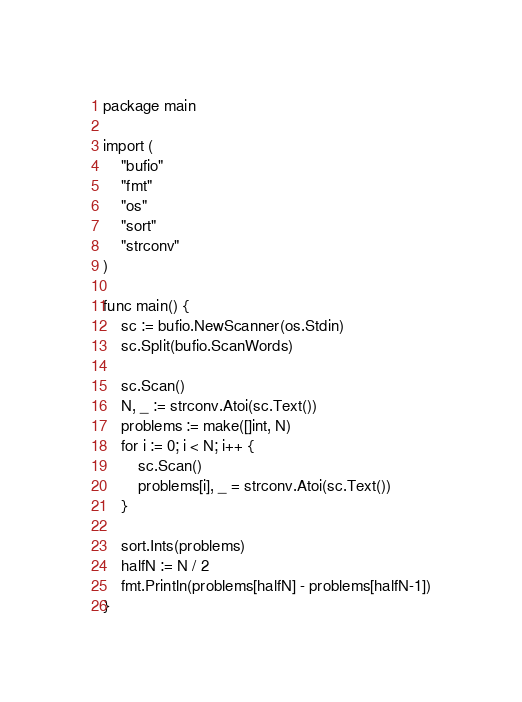<code> <loc_0><loc_0><loc_500><loc_500><_Go_>package main

import (
	"bufio"
	"fmt"
	"os"
	"sort"
	"strconv"
)

func main() {
	sc := bufio.NewScanner(os.Stdin)
	sc.Split(bufio.ScanWords)

	sc.Scan()
	N, _ := strconv.Atoi(sc.Text())
	problems := make([]int, N)
	for i := 0; i < N; i++ {
		sc.Scan()
		problems[i], _ = strconv.Atoi(sc.Text())
	}

	sort.Ints(problems)
	halfN := N / 2
	fmt.Println(problems[halfN] - problems[halfN-1])
}
</code> 